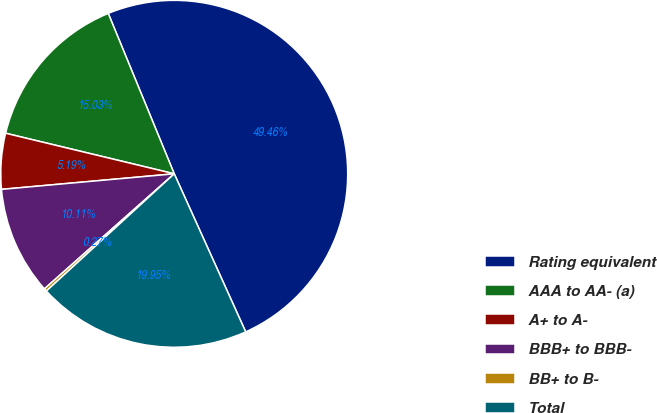Convert chart to OTSL. <chart><loc_0><loc_0><loc_500><loc_500><pie_chart><fcel>Rating equivalent<fcel>AAA to AA- (a)<fcel>A+ to A-<fcel>BBB+ to BBB-<fcel>BB+ to B-<fcel>Total<nl><fcel>49.46%<fcel>15.03%<fcel>5.19%<fcel>10.11%<fcel>0.27%<fcel>19.95%<nl></chart> 